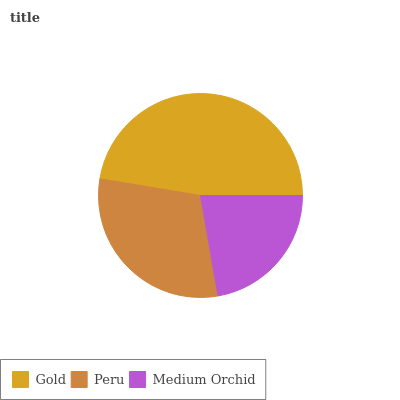Is Medium Orchid the minimum?
Answer yes or no. Yes. Is Gold the maximum?
Answer yes or no. Yes. Is Peru the minimum?
Answer yes or no. No. Is Peru the maximum?
Answer yes or no. No. Is Gold greater than Peru?
Answer yes or no. Yes. Is Peru less than Gold?
Answer yes or no. Yes. Is Peru greater than Gold?
Answer yes or no. No. Is Gold less than Peru?
Answer yes or no. No. Is Peru the high median?
Answer yes or no. Yes. Is Peru the low median?
Answer yes or no. Yes. Is Gold the high median?
Answer yes or no. No. Is Gold the low median?
Answer yes or no. No. 